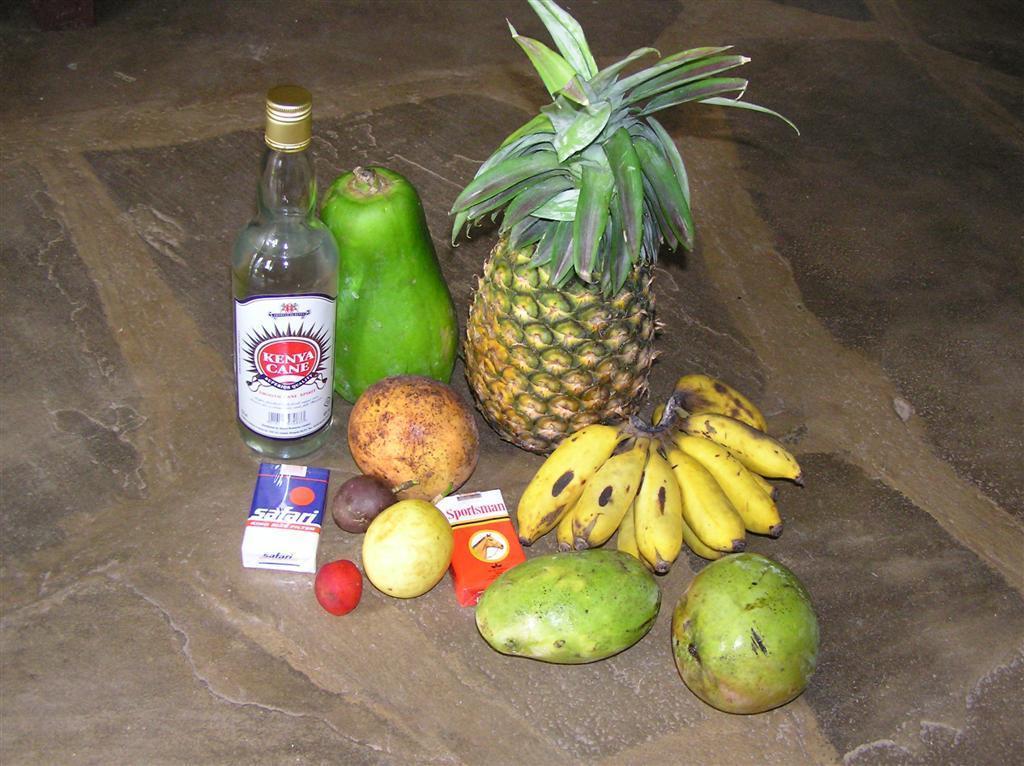In one or two sentences, can you explain what this image depicts? In this image we can see some fruits, a bottle and boxes on the ground. 